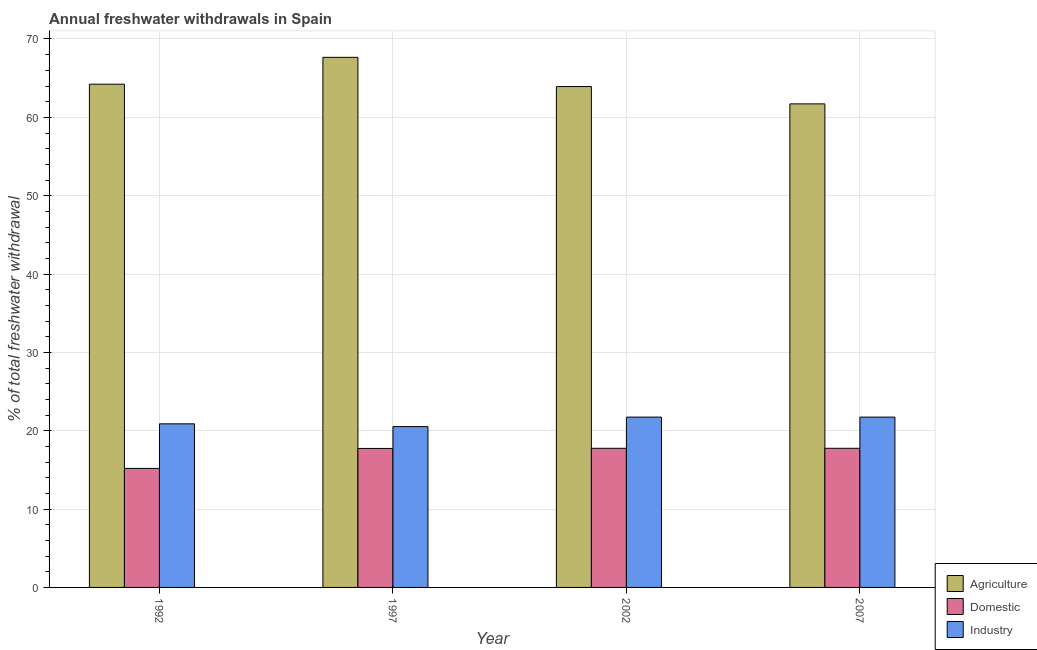How many different coloured bars are there?
Keep it short and to the point. 3. Are the number of bars per tick equal to the number of legend labels?
Provide a short and direct response. Yes. How many bars are there on the 2nd tick from the right?
Provide a short and direct response. 3. In how many cases, is the number of bars for a given year not equal to the number of legend labels?
Provide a short and direct response. 0. What is the percentage of freshwater withdrawal for industry in 1992?
Offer a very short reply. 20.88. Across all years, what is the maximum percentage of freshwater withdrawal for industry?
Offer a terse response. 21.74. Across all years, what is the minimum percentage of freshwater withdrawal for domestic purposes?
Your answer should be very brief. 15.19. In which year was the percentage of freshwater withdrawal for agriculture maximum?
Your answer should be compact. 1997. In which year was the percentage of freshwater withdrawal for domestic purposes minimum?
Give a very brief answer. 1992. What is the total percentage of freshwater withdrawal for domestic purposes in the graph?
Your answer should be very brief. 68.45. What is the difference between the percentage of freshwater withdrawal for agriculture in 2002 and that in 2007?
Your answer should be very brief. 2.21. What is the difference between the percentage of freshwater withdrawal for industry in 2007 and the percentage of freshwater withdrawal for domestic purposes in 2002?
Your answer should be compact. 0. What is the average percentage of freshwater withdrawal for domestic purposes per year?
Make the answer very short. 17.11. In the year 1992, what is the difference between the percentage of freshwater withdrawal for domestic purposes and percentage of freshwater withdrawal for agriculture?
Provide a succinct answer. 0. In how many years, is the percentage of freshwater withdrawal for domestic purposes greater than 32 %?
Keep it short and to the point. 0. What is the ratio of the percentage of freshwater withdrawal for industry in 1992 to that in 1997?
Your answer should be compact. 1.02. Is the percentage of freshwater withdrawal for industry in 1992 less than that in 2007?
Offer a very short reply. Yes. What is the difference between the highest and the second highest percentage of freshwater withdrawal for industry?
Give a very brief answer. 0. What is the difference between the highest and the lowest percentage of freshwater withdrawal for domestic purposes?
Offer a very short reply. 2.57. Is the sum of the percentage of freshwater withdrawal for agriculture in 2002 and 2007 greater than the maximum percentage of freshwater withdrawal for domestic purposes across all years?
Offer a very short reply. Yes. What does the 2nd bar from the left in 1997 represents?
Provide a succinct answer. Domestic. What does the 1st bar from the right in 1992 represents?
Offer a terse response. Industry. Is it the case that in every year, the sum of the percentage of freshwater withdrawal for agriculture and percentage of freshwater withdrawal for domestic purposes is greater than the percentage of freshwater withdrawal for industry?
Provide a short and direct response. Yes. How many bars are there?
Make the answer very short. 12. Are all the bars in the graph horizontal?
Your answer should be compact. No. Does the graph contain any zero values?
Keep it short and to the point. No. How many legend labels are there?
Provide a short and direct response. 3. What is the title of the graph?
Ensure brevity in your answer.  Annual freshwater withdrawals in Spain. What is the label or title of the Y-axis?
Give a very brief answer. % of total freshwater withdrawal. What is the % of total freshwater withdrawal of Agriculture in 1992?
Keep it short and to the point. 64.23. What is the % of total freshwater withdrawal in Domestic in 1992?
Provide a short and direct response. 15.19. What is the % of total freshwater withdrawal of Industry in 1992?
Ensure brevity in your answer.  20.88. What is the % of total freshwater withdrawal in Agriculture in 1997?
Your answer should be very brief. 67.66. What is the % of total freshwater withdrawal of Domestic in 1997?
Your response must be concise. 17.74. What is the % of total freshwater withdrawal in Industry in 1997?
Your answer should be very brief. 20.53. What is the % of total freshwater withdrawal of Agriculture in 2002?
Your answer should be compact. 63.93. What is the % of total freshwater withdrawal of Domestic in 2002?
Give a very brief answer. 17.76. What is the % of total freshwater withdrawal in Industry in 2002?
Your response must be concise. 21.74. What is the % of total freshwater withdrawal in Agriculture in 2007?
Ensure brevity in your answer.  61.72. What is the % of total freshwater withdrawal of Domestic in 2007?
Provide a succinct answer. 17.76. What is the % of total freshwater withdrawal in Industry in 2007?
Provide a succinct answer. 21.74. Across all years, what is the maximum % of total freshwater withdrawal of Agriculture?
Offer a very short reply. 67.66. Across all years, what is the maximum % of total freshwater withdrawal in Domestic?
Keep it short and to the point. 17.76. Across all years, what is the maximum % of total freshwater withdrawal of Industry?
Offer a very short reply. 21.74. Across all years, what is the minimum % of total freshwater withdrawal of Agriculture?
Offer a terse response. 61.72. Across all years, what is the minimum % of total freshwater withdrawal of Domestic?
Ensure brevity in your answer.  15.19. Across all years, what is the minimum % of total freshwater withdrawal of Industry?
Provide a succinct answer. 20.53. What is the total % of total freshwater withdrawal of Agriculture in the graph?
Ensure brevity in your answer.  257.54. What is the total % of total freshwater withdrawal of Domestic in the graph?
Your response must be concise. 68.45. What is the total % of total freshwater withdrawal of Industry in the graph?
Your response must be concise. 84.89. What is the difference between the % of total freshwater withdrawal of Agriculture in 1992 and that in 1997?
Offer a terse response. -3.43. What is the difference between the % of total freshwater withdrawal in Domestic in 1992 and that in 1997?
Make the answer very short. -2.55. What is the difference between the % of total freshwater withdrawal of Agriculture in 1992 and that in 2002?
Provide a succinct answer. 0.3. What is the difference between the % of total freshwater withdrawal in Domestic in 1992 and that in 2002?
Provide a succinct answer. -2.57. What is the difference between the % of total freshwater withdrawal of Industry in 1992 and that in 2002?
Provide a short and direct response. -0.86. What is the difference between the % of total freshwater withdrawal of Agriculture in 1992 and that in 2007?
Make the answer very short. 2.51. What is the difference between the % of total freshwater withdrawal of Domestic in 1992 and that in 2007?
Your answer should be very brief. -2.57. What is the difference between the % of total freshwater withdrawal in Industry in 1992 and that in 2007?
Provide a succinct answer. -0.86. What is the difference between the % of total freshwater withdrawal in Agriculture in 1997 and that in 2002?
Your answer should be very brief. 3.73. What is the difference between the % of total freshwater withdrawal in Domestic in 1997 and that in 2002?
Your answer should be compact. -0.02. What is the difference between the % of total freshwater withdrawal in Industry in 1997 and that in 2002?
Your answer should be very brief. -1.21. What is the difference between the % of total freshwater withdrawal in Agriculture in 1997 and that in 2007?
Provide a short and direct response. 5.94. What is the difference between the % of total freshwater withdrawal in Domestic in 1997 and that in 2007?
Keep it short and to the point. -0.02. What is the difference between the % of total freshwater withdrawal in Industry in 1997 and that in 2007?
Keep it short and to the point. -1.21. What is the difference between the % of total freshwater withdrawal in Agriculture in 2002 and that in 2007?
Your answer should be compact. 2.21. What is the difference between the % of total freshwater withdrawal of Industry in 2002 and that in 2007?
Ensure brevity in your answer.  0. What is the difference between the % of total freshwater withdrawal of Agriculture in 1992 and the % of total freshwater withdrawal of Domestic in 1997?
Your answer should be very brief. 46.49. What is the difference between the % of total freshwater withdrawal of Agriculture in 1992 and the % of total freshwater withdrawal of Industry in 1997?
Offer a very short reply. 43.7. What is the difference between the % of total freshwater withdrawal of Domestic in 1992 and the % of total freshwater withdrawal of Industry in 1997?
Make the answer very short. -5.34. What is the difference between the % of total freshwater withdrawal of Agriculture in 1992 and the % of total freshwater withdrawal of Domestic in 2002?
Give a very brief answer. 46.47. What is the difference between the % of total freshwater withdrawal of Agriculture in 1992 and the % of total freshwater withdrawal of Industry in 2002?
Give a very brief answer. 42.49. What is the difference between the % of total freshwater withdrawal of Domestic in 1992 and the % of total freshwater withdrawal of Industry in 2002?
Keep it short and to the point. -6.55. What is the difference between the % of total freshwater withdrawal of Agriculture in 1992 and the % of total freshwater withdrawal of Domestic in 2007?
Your answer should be compact. 46.47. What is the difference between the % of total freshwater withdrawal in Agriculture in 1992 and the % of total freshwater withdrawal in Industry in 2007?
Give a very brief answer. 42.49. What is the difference between the % of total freshwater withdrawal in Domestic in 1992 and the % of total freshwater withdrawal in Industry in 2007?
Ensure brevity in your answer.  -6.55. What is the difference between the % of total freshwater withdrawal of Agriculture in 1997 and the % of total freshwater withdrawal of Domestic in 2002?
Ensure brevity in your answer.  49.9. What is the difference between the % of total freshwater withdrawal in Agriculture in 1997 and the % of total freshwater withdrawal in Industry in 2002?
Your answer should be compact. 45.92. What is the difference between the % of total freshwater withdrawal in Agriculture in 1997 and the % of total freshwater withdrawal in Domestic in 2007?
Offer a terse response. 49.9. What is the difference between the % of total freshwater withdrawal in Agriculture in 1997 and the % of total freshwater withdrawal in Industry in 2007?
Give a very brief answer. 45.92. What is the difference between the % of total freshwater withdrawal of Domestic in 1997 and the % of total freshwater withdrawal of Industry in 2007?
Offer a terse response. -4. What is the difference between the % of total freshwater withdrawal in Agriculture in 2002 and the % of total freshwater withdrawal in Domestic in 2007?
Ensure brevity in your answer.  46.17. What is the difference between the % of total freshwater withdrawal of Agriculture in 2002 and the % of total freshwater withdrawal of Industry in 2007?
Your answer should be very brief. 42.19. What is the difference between the % of total freshwater withdrawal of Domestic in 2002 and the % of total freshwater withdrawal of Industry in 2007?
Provide a succinct answer. -3.98. What is the average % of total freshwater withdrawal in Agriculture per year?
Offer a terse response. 64.39. What is the average % of total freshwater withdrawal of Domestic per year?
Your answer should be compact. 17.11. What is the average % of total freshwater withdrawal in Industry per year?
Your answer should be compact. 21.22. In the year 1992, what is the difference between the % of total freshwater withdrawal in Agriculture and % of total freshwater withdrawal in Domestic?
Give a very brief answer. 49.04. In the year 1992, what is the difference between the % of total freshwater withdrawal in Agriculture and % of total freshwater withdrawal in Industry?
Your response must be concise. 43.35. In the year 1992, what is the difference between the % of total freshwater withdrawal in Domestic and % of total freshwater withdrawal in Industry?
Make the answer very short. -5.69. In the year 1997, what is the difference between the % of total freshwater withdrawal of Agriculture and % of total freshwater withdrawal of Domestic?
Offer a terse response. 49.92. In the year 1997, what is the difference between the % of total freshwater withdrawal of Agriculture and % of total freshwater withdrawal of Industry?
Make the answer very short. 47.13. In the year 1997, what is the difference between the % of total freshwater withdrawal in Domestic and % of total freshwater withdrawal in Industry?
Provide a succinct answer. -2.79. In the year 2002, what is the difference between the % of total freshwater withdrawal in Agriculture and % of total freshwater withdrawal in Domestic?
Give a very brief answer. 46.17. In the year 2002, what is the difference between the % of total freshwater withdrawal of Agriculture and % of total freshwater withdrawal of Industry?
Make the answer very short. 42.19. In the year 2002, what is the difference between the % of total freshwater withdrawal in Domestic and % of total freshwater withdrawal in Industry?
Ensure brevity in your answer.  -3.98. In the year 2007, what is the difference between the % of total freshwater withdrawal of Agriculture and % of total freshwater withdrawal of Domestic?
Provide a succinct answer. 43.96. In the year 2007, what is the difference between the % of total freshwater withdrawal of Agriculture and % of total freshwater withdrawal of Industry?
Ensure brevity in your answer.  39.98. In the year 2007, what is the difference between the % of total freshwater withdrawal in Domestic and % of total freshwater withdrawal in Industry?
Give a very brief answer. -3.98. What is the ratio of the % of total freshwater withdrawal in Agriculture in 1992 to that in 1997?
Provide a short and direct response. 0.95. What is the ratio of the % of total freshwater withdrawal of Domestic in 1992 to that in 1997?
Provide a short and direct response. 0.86. What is the ratio of the % of total freshwater withdrawal in Domestic in 1992 to that in 2002?
Give a very brief answer. 0.86. What is the ratio of the % of total freshwater withdrawal in Industry in 1992 to that in 2002?
Keep it short and to the point. 0.96. What is the ratio of the % of total freshwater withdrawal in Agriculture in 1992 to that in 2007?
Keep it short and to the point. 1.04. What is the ratio of the % of total freshwater withdrawal of Domestic in 1992 to that in 2007?
Provide a succinct answer. 0.86. What is the ratio of the % of total freshwater withdrawal in Industry in 1992 to that in 2007?
Offer a very short reply. 0.96. What is the ratio of the % of total freshwater withdrawal of Agriculture in 1997 to that in 2002?
Your answer should be very brief. 1.06. What is the ratio of the % of total freshwater withdrawal in Industry in 1997 to that in 2002?
Keep it short and to the point. 0.94. What is the ratio of the % of total freshwater withdrawal in Agriculture in 1997 to that in 2007?
Make the answer very short. 1.1. What is the ratio of the % of total freshwater withdrawal in Industry in 1997 to that in 2007?
Provide a succinct answer. 0.94. What is the ratio of the % of total freshwater withdrawal in Agriculture in 2002 to that in 2007?
Your answer should be very brief. 1.04. What is the ratio of the % of total freshwater withdrawal in Domestic in 2002 to that in 2007?
Provide a succinct answer. 1. What is the difference between the highest and the second highest % of total freshwater withdrawal in Agriculture?
Make the answer very short. 3.43. What is the difference between the highest and the second highest % of total freshwater withdrawal in Domestic?
Your answer should be very brief. 0. What is the difference between the highest and the second highest % of total freshwater withdrawal of Industry?
Keep it short and to the point. 0. What is the difference between the highest and the lowest % of total freshwater withdrawal of Agriculture?
Give a very brief answer. 5.94. What is the difference between the highest and the lowest % of total freshwater withdrawal of Domestic?
Make the answer very short. 2.57. What is the difference between the highest and the lowest % of total freshwater withdrawal of Industry?
Provide a short and direct response. 1.21. 